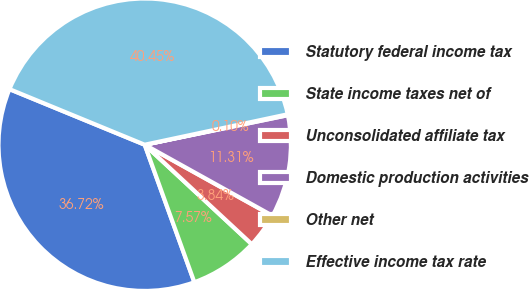Convert chart. <chart><loc_0><loc_0><loc_500><loc_500><pie_chart><fcel>Statutory federal income tax<fcel>State income taxes net of<fcel>Unconsolidated affiliate tax<fcel>Domestic production activities<fcel>Other net<fcel>Effective income tax rate<nl><fcel>36.72%<fcel>7.57%<fcel>3.84%<fcel>11.31%<fcel>0.1%<fcel>40.45%<nl></chart> 